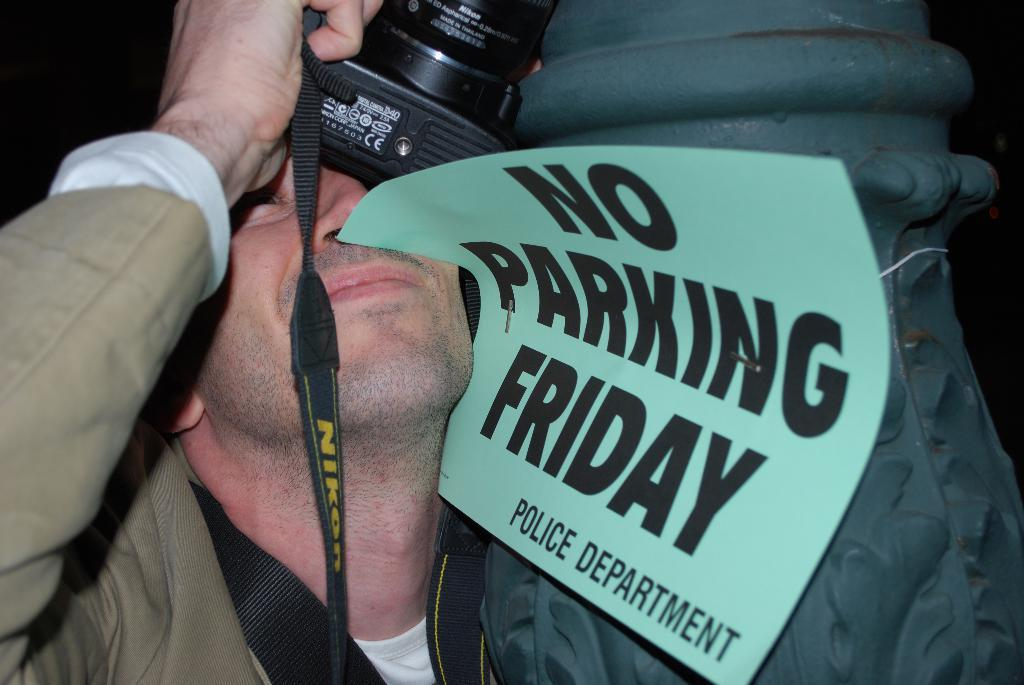What is the man in the image holding? The man is holding a camera. What else can be seen in the image besides the man and the camera? There is a paper in the image. What is written on the paper? The paper has "no parking police department" written on it. How is the paper positioned in the image? The paper is stuck on the man's face. What type of hose is the man using to water the plants in the image? There is no hose present in the image, and the man is not watering any plants. Is there any snow visible in the image? No, there is no snow visible in the image. 